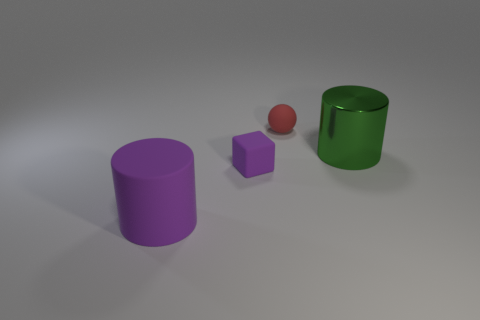Add 1 big matte cylinders. How many objects exist? 5 Subtract all green cylinders. How many cylinders are left? 1 Subtract all balls. How many objects are left? 3 Subtract 1 spheres. How many spheres are left? 0 Add 3 purple matte objects. How many purple matte objects are left? 5 Add 3 red matte objects. How many red matte objects exist? 4 Subtract 1 red spheres. How many objects are left? 3 Subtract all purple cylinders. Subtract all green balls. How many cylinders are left? 1 Subtract all green shiny things. Subtract all tiny rubber blocks. How many objects are left? 2 